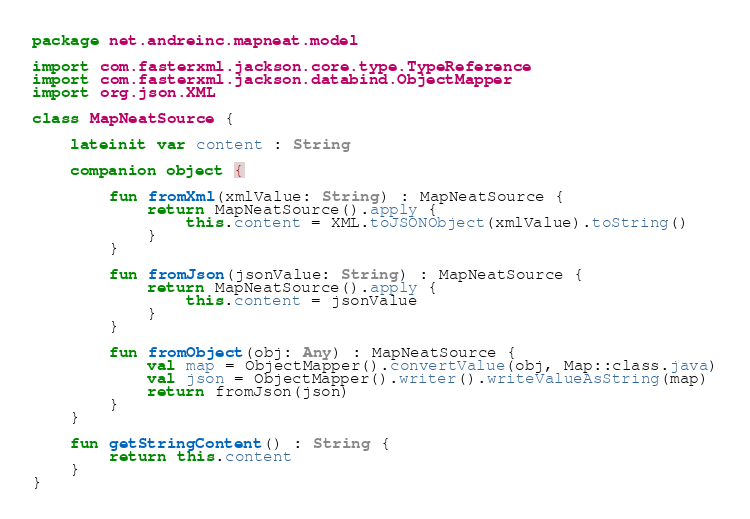Convert code to text. <code><loc_0><loc_0><loc_500><loc_500><_Kotlin_>package net.andreinc.mapneat.model

import com.fasterxml.jackson.core.type.TypeReference
import com.fasterxml.jackson.databind.ObjectMapper
import org.json.XML

class MapNeatSource {

    lateinit var content : String

    companion object {

        fun fromXml(xmlValue: String) : MapNeatSource {
            return MapNeatSource().apply {
                this.content = XML.toJSONObject(xmlValue).toString()
            }
        }

        fun fromJson(jsonValue: String) : MapNeatSource {
            return MapNeatSource().apply {
                this.content = jsonValue
            }
        }

        fun fromObject(obj: Any) : MapNeatSource {
            val map = ObjectMapper().convertValue(obj, Map::class.java)
            val json = ObjectMapper().writer().writeValueAsString(map)
            return fromJson(json)
        }
    }

    fun getStringContent() : String {
        return this.content
    }
}
</code> 